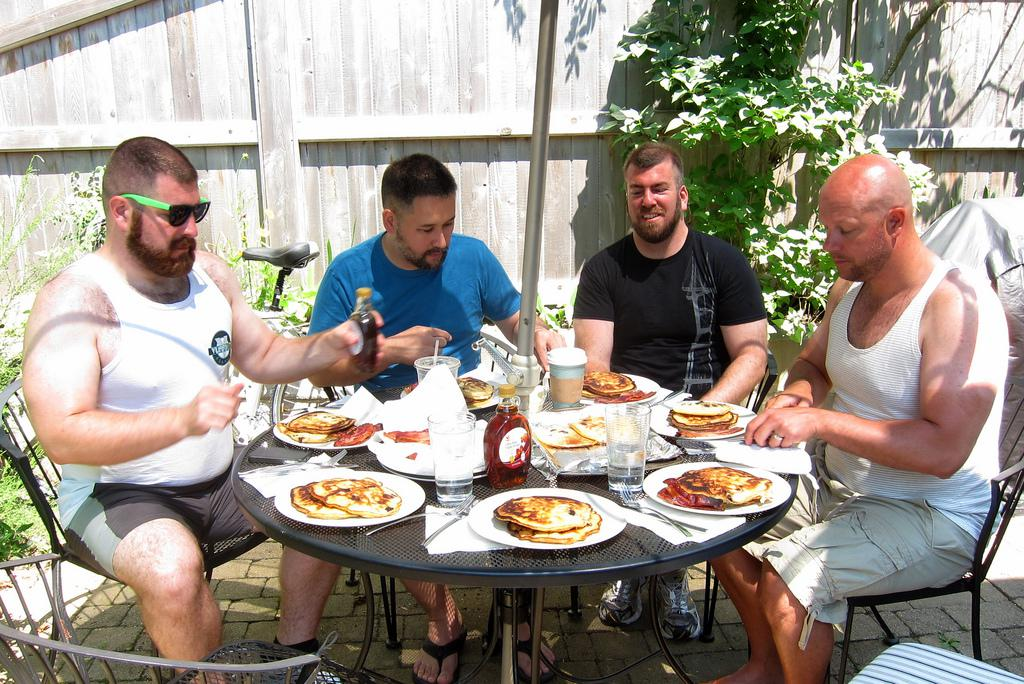Question: what meal does this appear to be?
Choices:
A. Lunch.
B. Dinner.
C. Brunch.
D. Breakfast.
Answer with the letter. Answer: D Question: what are these people doing?
Choices:
A. Drinking.
B. Eating.
C. Snacking.
D. Smoking.
Answer with the letter. Answer: B Question: what are they eating?
Choices:
A. Bacon.
B. Pancakes.
C. Hashbrowns.
D. Eggs.
Answer with the letter. Answer: B Question: what is the man in blue wearing for shoes?
Choices:
A. Running shoes.
B. Flip flops.
C. Dress shoes.
D. Tennis shoes.
Answer with the letter. Answer: B Question: what shape is the table?
Choices:
A. Round.
B. Oval.
C. Square.
D. Rectangular.
Answer with the letter. Answer: A Question: how many men are at the table?
Choices:
A. Three.
B. Four.
C. Six.
D. Eight.
Answer with the letter. Answer: B Question: who wears a blue shirt?
Choices:
A. A man.
B. The boy.
C. The girl.
D. The mother.
Answer with the letter. Answer: A Question: where are the men eating pancakes?
Choices:
A. The house.
B. At work.
C. In a restaurant.
D. At school.
Answer with the letter. Answer: C Question: where are they eating?
Choices:
A. On chair.
B. On table.
C. On bed.
D. On sofa.
Answer with the letter. Answer: B Question: where is the photo set?
Choices:
A. In a backyard.
B. Movie set.
C. The side yard.
D. The playing field.
Answer with the letter. Answer: A Question: who wears shades?
Choices:
A. One man.
B. The teenage girls.
C. The traffic cop.
D. The sunbather.
Answer with the letter. Answer: A Question: what color are the sunglasses?
Choices:
A. Black.
B. Brown.
C. White.
D. Green.
Answer with the letter. Answer: D Question: what is in the background?
Choices:
A. Two boys kicking a soccer ball.
B. An orange cat.
C. A maple tree.
D. Wooden fence.
Answer with the letter. Answer: D Question: who has a beard?
Choices:
A. The goat.
B. The teenager.
C. The old man.
D. All of the men.
Answer with the letter. Answer: D Question: where is the plant?
Choices:
A. Growing up the fence.
B. In the garden.
C. By the window.
D. Inside the house.
Answer with the letter. Answer: A Question: how many men are eating?
Choices:
A. Two.
B. Three.
C. Five.
D. Four.
Answer with the letter. Answer: D Question: what are in the scene?
Choices:
A. Blurs.
B. Smog.
C. Shadows.
D. Dust.
Answer with the letter. Answer: C Question: where are the men looking?
Choices:
A. Up.
B. Around.
C. Side ways.
D. Down.
Answer with the letter. Answer: D Question: how do the pancakes seem?
Choices:
A. Slightly burnt.
B. Slightly raw.
C. Slightly dense.
D. Slightly flat.
Answer with the letter. Answer: A Question: how many men wear white shirts?
Choices:
A. Two.
B. Three.
C. Four.
D. Five.
Answer with the letter. Answer: A 